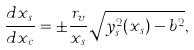Convert formula to latex. <formula><loc_0><loc_0><loc_500><loc_500>\frac { d x _ { s } } { d x _ { c } } = \pm \frac { r _ { v } } { x _ { s } } \sqrt { y _ { s } ^ { 2 } ( x _ { s } ) - b ^ { 2 } } ,</formula> 